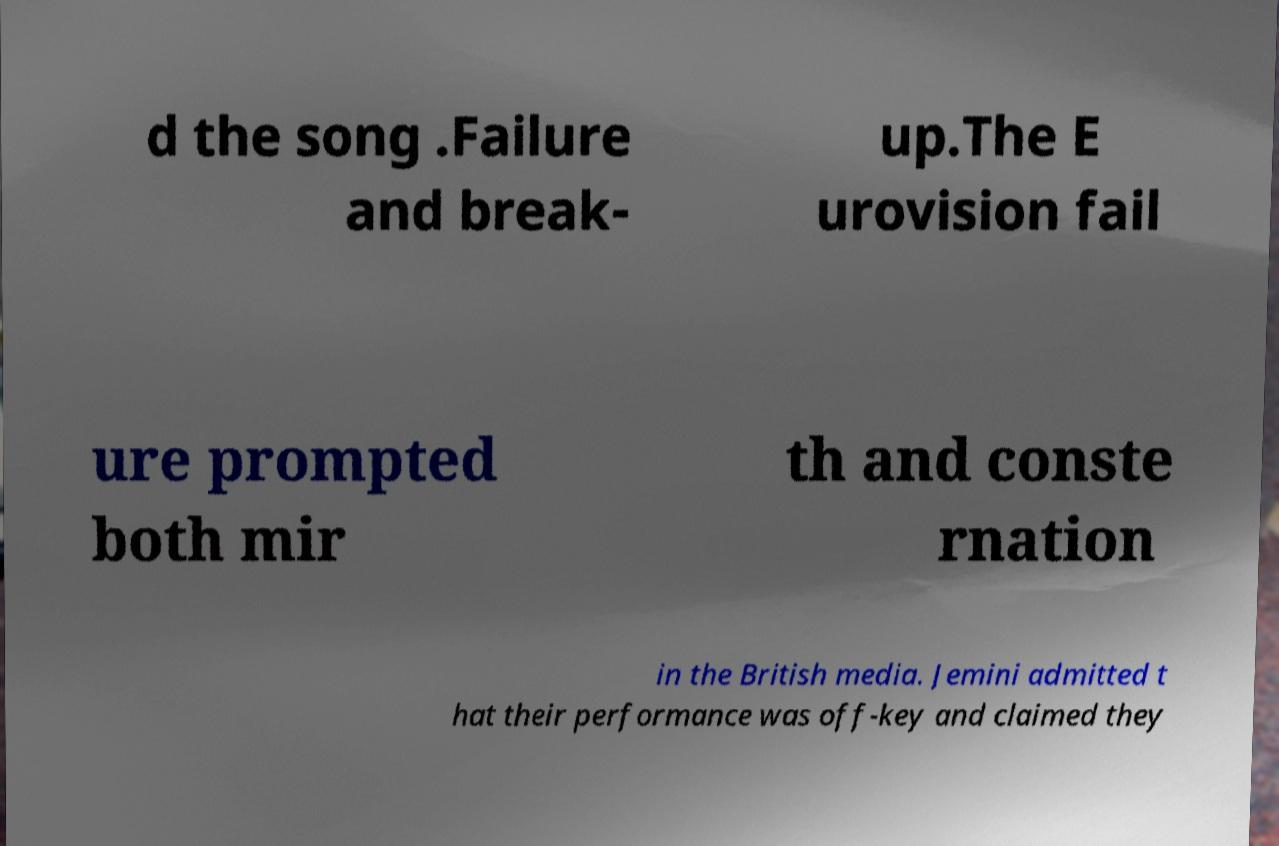Please identify and transcribe the text found in this image. d the song .Failure and break- up.The E urovision fail ure prompted both mir th and conste rnation in the British media. Jemini admitted t hat their performance was off-key and claimed they 